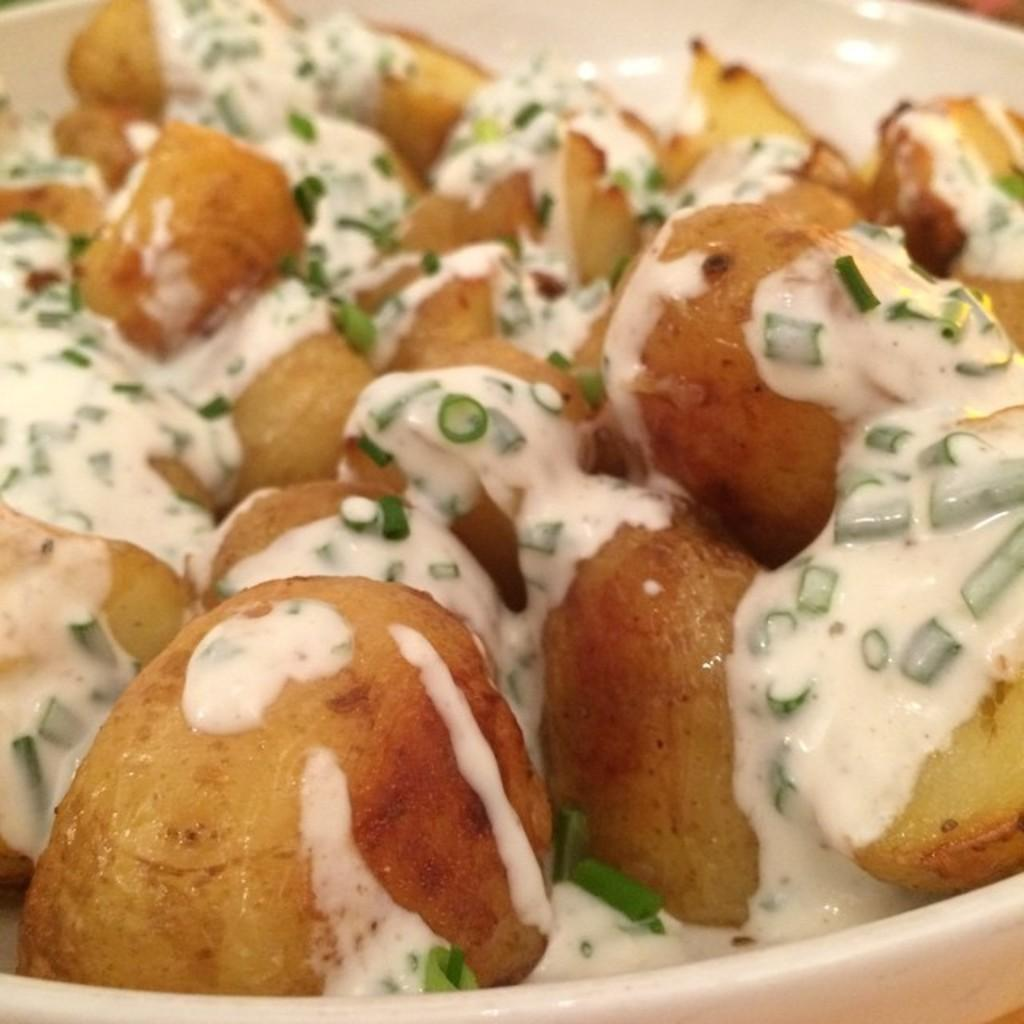What is placed on a plate in the image? There is a food item placed on a plate in the image. What type of pies can be seen in the image? There is no mention of pies in the provided fact, and therefore no such information can be determined from the image. 